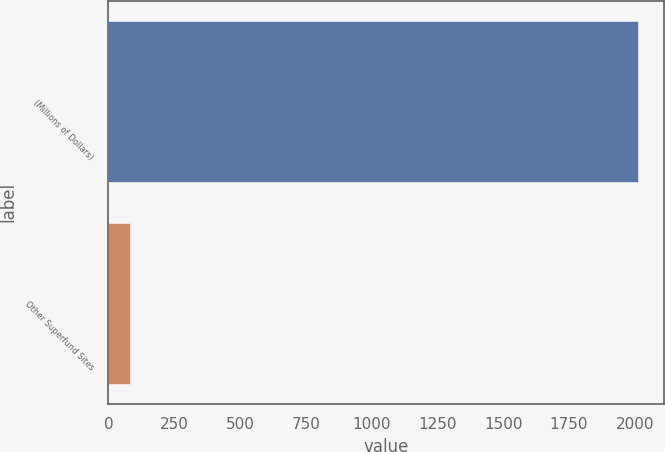<chart> <loc_0><loc_0><loc_500><loc_500><bar_chart><fcel>(Millions of Dollars)<fcel>Other Superfund Sites<nl><fcel>2012<fcel>82<nl></chart> 